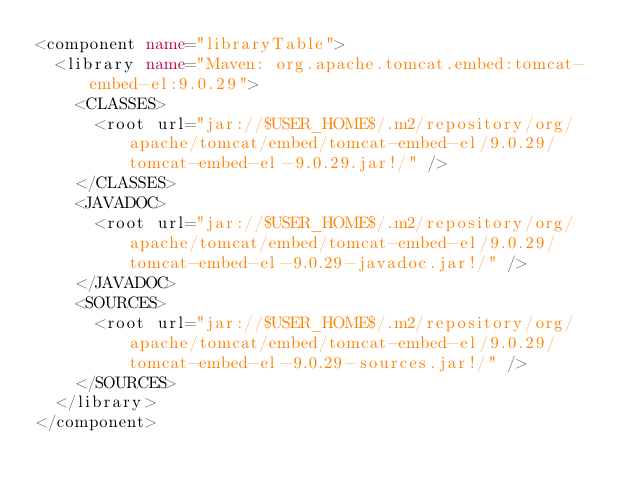<code> <loc_0><loc_0><loc_500><loc_500><_XML_><component name="libraryTable">
  <library name="Maven: org.apache.tomcat.embed:tomcat-embed-el:9.0.29">
    <CLASSES>
      <root url="jar://$USER_HOME$/.m2/repository/org/apache/tomcat/embed/tomcat-embed-el/9.0.29/tomcat-embed-el-9.0.29.jar!/" />
    </CLASSES>
    <JAVADOC>
      <root url="jar://$USER_HOME$/.m2/repository/org/apache/tomcat/embed/tomcat-embed-el/9.0.29/tomcat-embed-el-9.0.29-javadoc.jar!/" />
    </JAVADOC>
    <SOURCES>
      <root url="jar://$USER_HOME$/.m2/repository/org/apache/tomcat/embed/tomcat-embed-el/9.0.29/tomcat-embed-el-9.0.29-sources.jar!/" />
    </SOURCES>
  </library>
</component></code> 